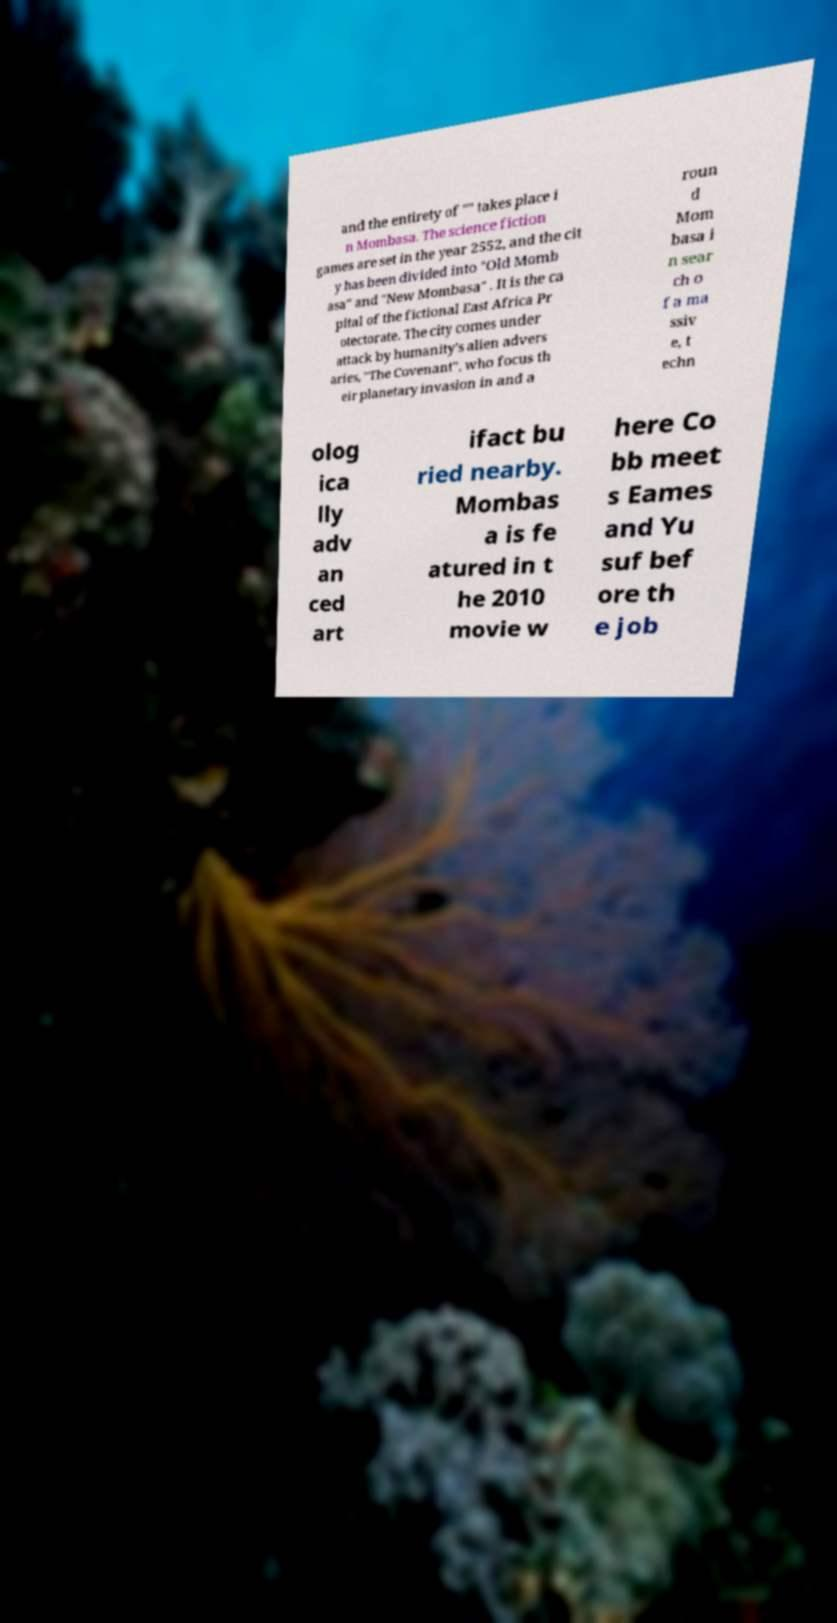Can you read and provide the text displayed in the image?This photo seems to have some interesting text. Can you extract and type it out for me? and the entirety of "" takes place i n Mombasa. The science fiction games are set in the year 2552, and the cit y has been divided into "Old Momb asa" and "New Mombasa" . It is the ca pital of the fictional East Africa Pr otectorate. The city comes under attack by humanity's alien advers aries, "The Covenant", who focus th eir planetary invasion in and a roun d Mom basa i n sear ch o f a ma ssiv e, t echn olog ica lly adv an ced art ifact bu ried nearby. Mombas a is fe atured in t he 2010 movie w here Co bb meet s Eames and Yu suf bef ore th e job 